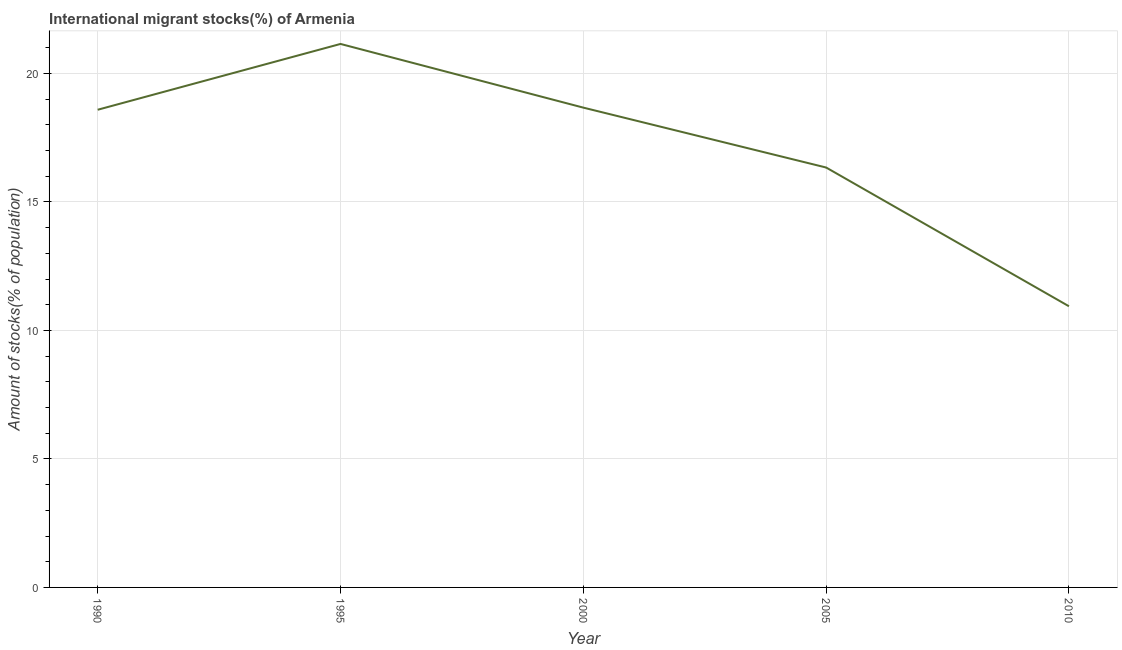What is the number of international migrant stocks in 2000?
Your response must be concise. 18.67. Across all years, what is the maximum number of international migrant stocks?
Provide a succinct answer. 21.15. Across all years, what is the minimum number of international migrant stocks?
Offer a very short reply. 10.94. What is the sum of the number of international migrant stocks?
Make the answer very short. 85.68. What is the difference between the number of international migrant stocks in 1995 and 2005?
Offer a very short reply. 4.81. What is the average number of international migrant stocks per year?
Offer a terse response. 17.14. What is the median number of international migrant stocks?
Your answer should be compact. 18.59. In how many years, is the number of international migrant stocks greater than 18 %?
Your response must be concise. 3. What is the ratio of the number of international migrant stocks in 1995 to that in 2000?
Provide a succinct answer. 1.13. What is the difference between the highest and the second highest number of international migrant stocks?
Provide a short and direct response. 2.48. What is the difference between the highest and the lowest number of international migrant stocks?
Ensure brevity in your answer.  10.21. In how many years, is the number of international migrant stocks greater than the average number of international migrant stocks taken over all years?
Ensure brevity in your answer.  3. Does the number of international migrant stocks monotonically increase over the years?
Give a very brief answer. No. What is the difference between two consecutive major ticks on the Y-axis?
Give a very brief answer. 5. Does the graph contain grids?
Offer a terse response. Yes. What is the title of the graph?
Your answer should be very brief. International migrant stocks(%) of Armenia. What is the label or title of the Y-axis?
Your response must be concise. Amount of stocks(% of population). What is the Amount of stocks(% of population) of 1990?
Your response must be concise. 18.59. What is the Amount of stocks(% of population) of 1995?
Make the answer very short. 21.15. What is the Amount of stocks(% of population) in 2000?
Offer a terse response. 18.67. What is the Amount of stocks(% of population) of 2005?
Offer a very short reply. 16.34. What is the Amount of stocks(% of population) in 2010?
Your response must be concise. 10.94. What is the difference between the Amount of stocks(% of population) in 1990 and 1995?
Offer a terse response. -2.56. What is the difference between the Amount of stocks(% of population) in 1990 and 2000?
Provide a short and direct response. -0.08. What is the difference between the Amount of stocks(% of population) in 1990 and 2005?
Your answer should be very brief. 2.25. What is the difference between the Amount of stocks(% of population) in 1990 and 2010?
Provide a short and direct response. 7.65. What is the difference between the Amount of stocks(% of population) in 1995 and 2000?
Keep it short and to the point. 2.48. What is the difference between the Amount of stocks(% of population) in 1995 and 2005?
Provide a short and direct response. 4.81. What is the difference between the Amount of stocks(% of population) in 1995 and 2010?
Provide a succinct answer. 10.21. What is the difference between the Amount of stocks(% of population) in 2000 and 2005?
Provide a short and direct response. 2.33. What is the difference between the Amount of stocks(% of population) in 2000 and 2010?
Your answer should be very brief. 7.73. What is the difference between the Amount of stocks(% of population) in 2005 and 2010?
Make the answer very short. 5.4. What is the ratio of the Amount of stocks(% of population) in 1990 to that in 1995?
Provide a succinct answer. 0.88. What is the ratio of the Amount of stocks(% of population) in 1990 to that in 2000?
Provide a short and direct response. 1. What is the ratio of the Amount of stocks(% of population) in 1990 to that in 2005?
Offer a terse response. 1.14. What is the ratio of the Amount of stocks(% of population) in 1990 to that in 2010?
Keep it short and to the point. 1.7. What is the ratio of the Amount of stocks(% of population) in 1995 to that in 2000?
Your response must be concise. 1.13. What is the ratio of the Amount of stocks(% of population) in 1995 to that in 2005?
Your response must be concise. 1.29. What is the ratio of the Amount of stocks(% of population) in 1995 to that in 2010?
Your answer should be compact. 1.93. What is the ratio of the Amount of stocks(% of population) in 2000 to that in 2005?
Provide a succinct answer. 1.14. What is the ratio of the Amount of stocks(% of population) in 2000 to that in 2010?
Offer a very short reply. 1.71. What is the ratio of the Amount of stocks(% of population) in 2005 to that in 2010?
Your answer should be compact. 1.49. 